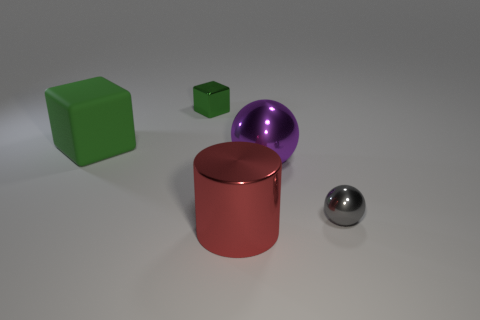Subtract 0 blue spheres. How many objects are left? 5 Subtract all cubes. How many objects are left? 3 Subtract 1 cylinders. How many cylinders are left? 0 Subtract all yellow balls. Subtract all brown blocks. How many balls are left? 2 Subtract all red cubes. How many purple spheres are left? 1 Subtract all purple things. Subtract all tiny yellow cubes. How many objects are left? 4 Add 4 matte objects. How many matte objects are left? 5 Add 3 big yellow things. How many big yellow things exist? 3 Add 4 small shiny objects. How many objects exist? 9 Subtract all gray balls. How many balls are left? 1 